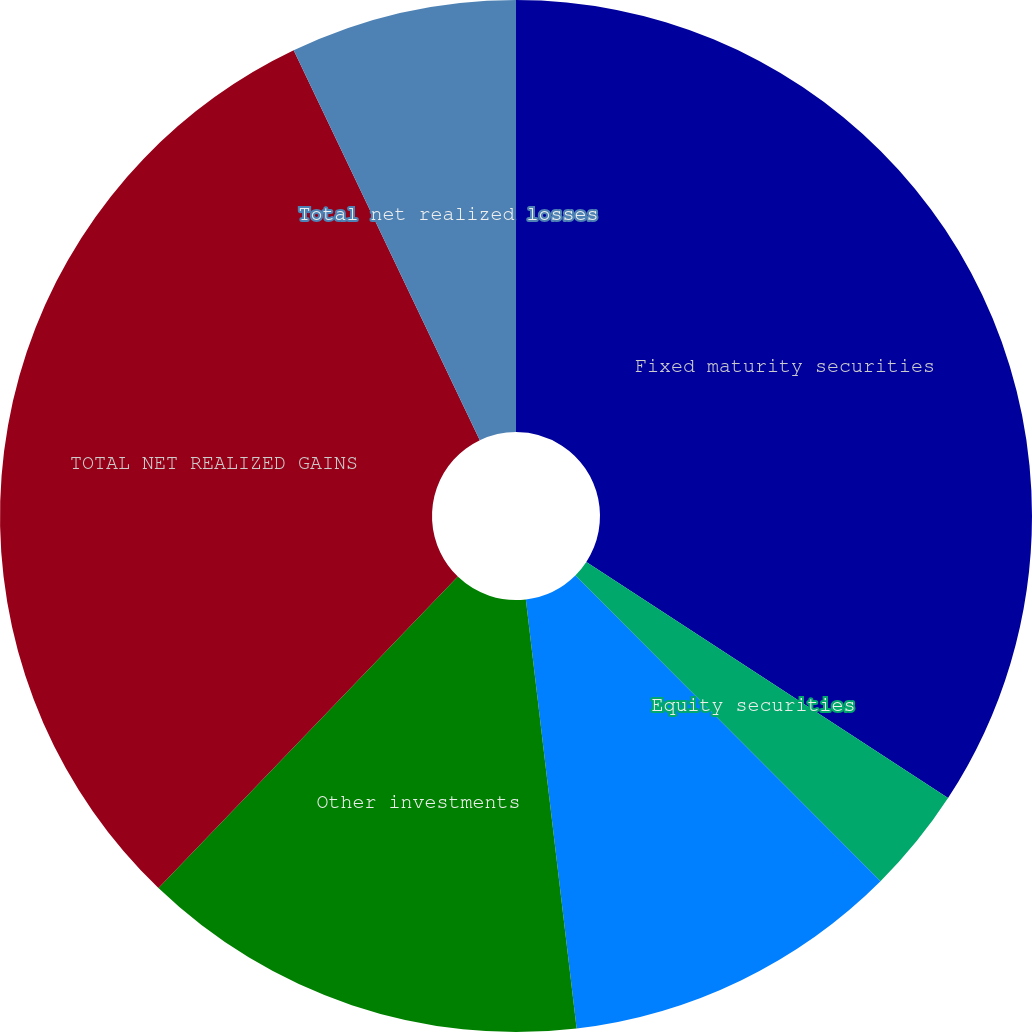Convert chart to OTSL. <chart><loc_0><loc_0><loc_500><loc_500><pie_chart><fcel>Fixed maturity securities<fcel>Equity securities<fcel>Commercial mortgage loans on<fcel>Other investments<fcel>TOTAL NET REALIZED GAINS<fcel>Total net realized losses<nl><fcel>34.21%<fcel>3.31%<fcel>10.61%<fcel>14.06%<fcel>30.73%<fcel>7.09%<nl></chart> 